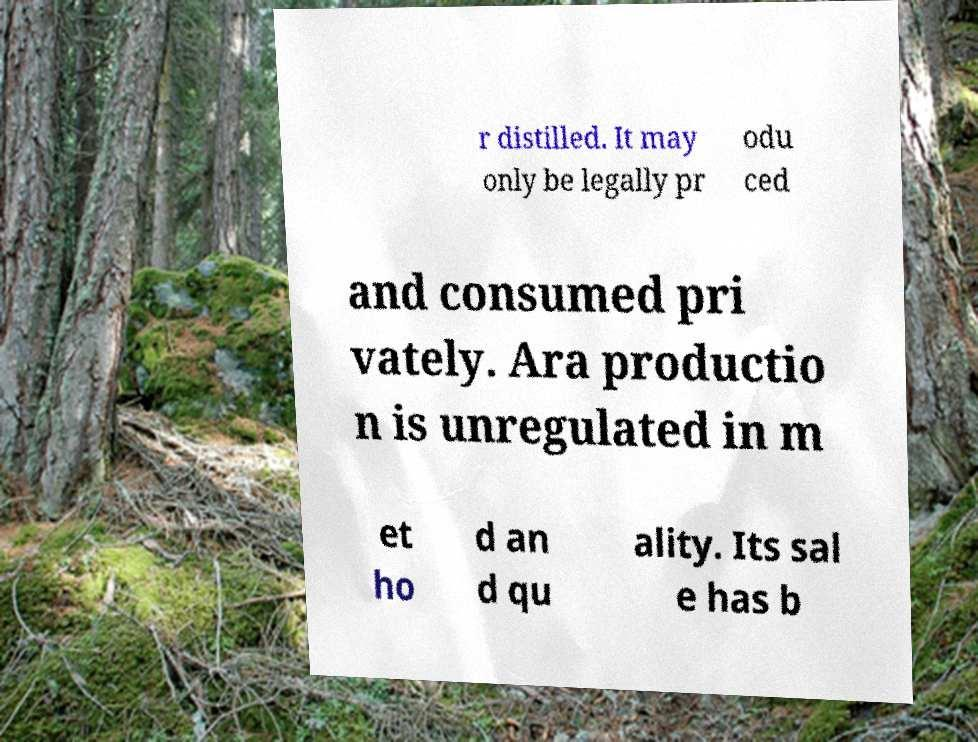For documentation purposes, I need the text within this image transcribed. Could you provide that? r distilled. It may only be legally pr odu ced and consumed pri vately. Ara productio n is unregulated in m et ho d an d qu ality. Its sal e has b 